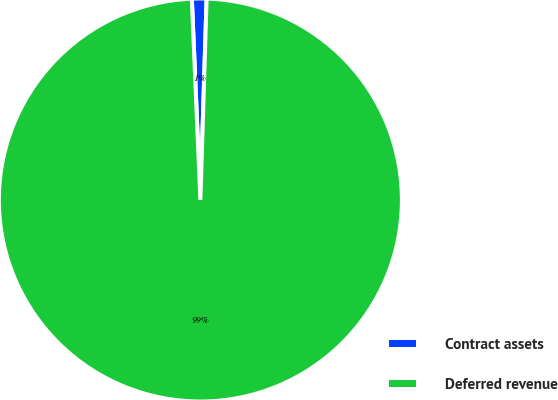Convert chart to OTSL. <chart><loc_0><loc_0><loc_500><loc_500><pie_chart><fcel>Contract assets<fcel>Deferred revenue<nl><fcel>1.17%<fcel>98.83%<nl></chart> 